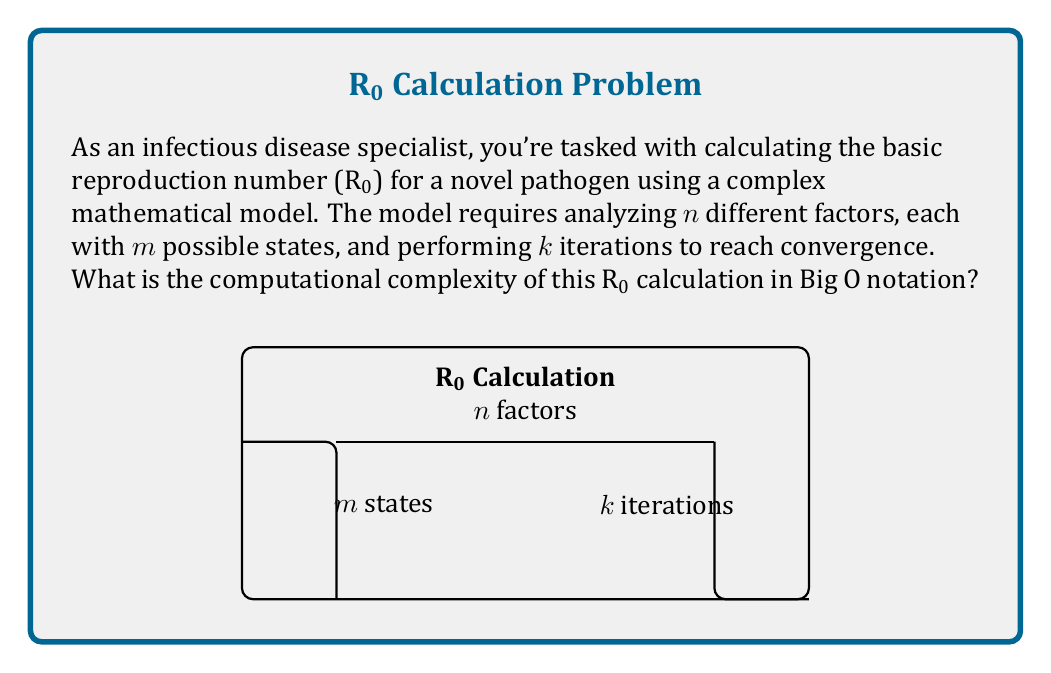Can you answer this question? To determine the computational complexity, let's break down the problem:

1) We have $n$ factors, each with $m$ possible states. This means we need to consider $m^n$ combinations of factor states.

2) For each combination, we perform $k$ iterations to reach convergence.

3) The basic operation in each iteration is likely to involve all $n$ factors.

Therefore, the total number of operations can be expressed as:

$$ \text{Total Operations} = m^n \cdot k \cdot n $$

In Big O notation, we focus on the most significant terms as the input size grows. Here, $m^n$ is typically the dominant term, especially as $n$ increases.

The complexity can be written as:

$$ O(m^n \cdot k \cdot n) $$

However, since $k$ (number of iterations) is often considered a constant in many algorithmic analyses, we can simplify this to:

$$ O(m^n \cdot n) $$

This represents an exponential time complexity with respect to the number of factors $n$, which is characteristic of many problems involving multiple interacting variables in epidemiological models.
Answer: $O(m^n \cdot n)$ 